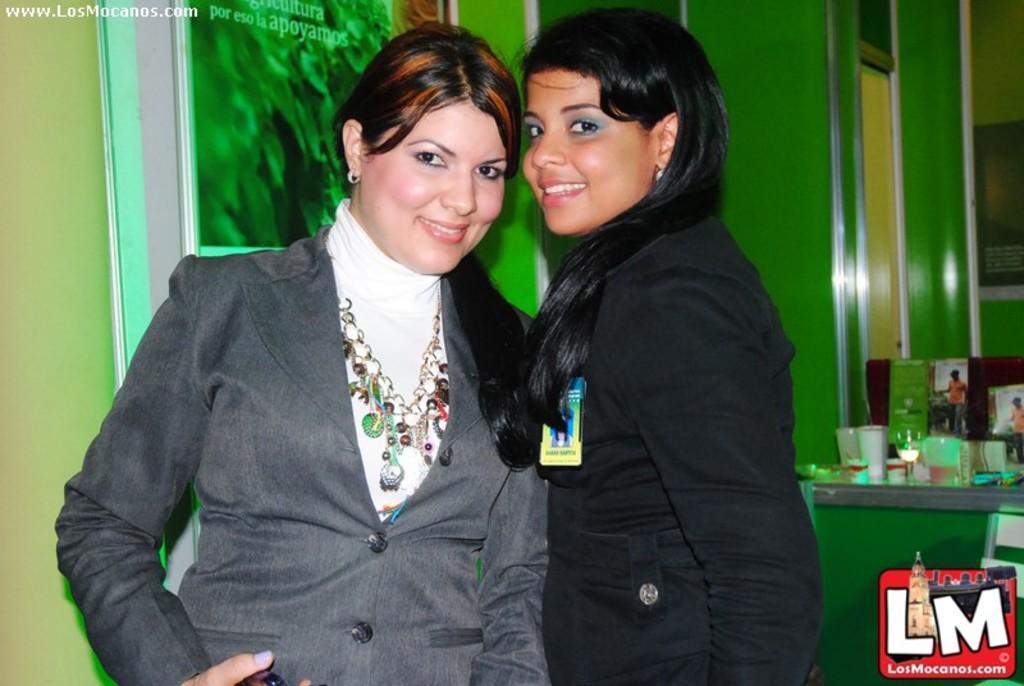In one or two sentences, can you explain what this image depicts? In this picture I can see two persons standing and smiling, there are cups and some other objects on the table, and in the background there are frames attached to the wall and there are watermarks on the image. 